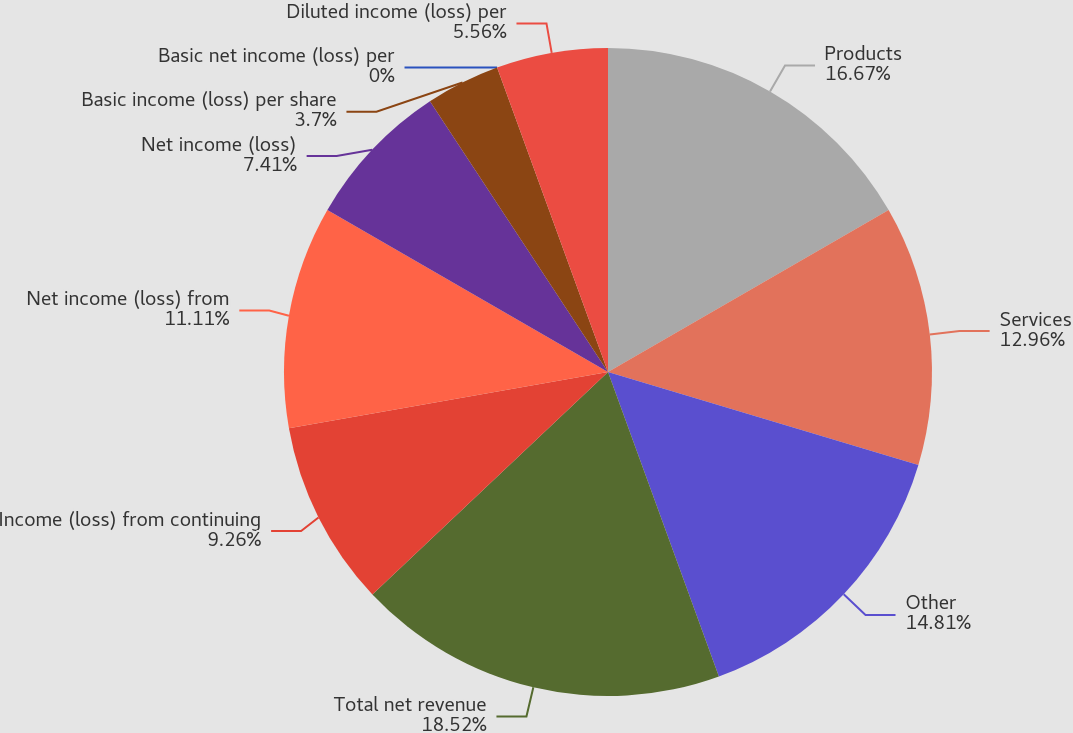<chart> <loc_0><loc_0><loc_500><loc_500><pie_chart><fcel>Products<fcel>Services<fcel>Other<fcel>Total net revenue<fcel>Income (loss) from continuing<fcel>Net income (loss) from<fcel>Net income (loss)<fcel>Basic income (loss) per share<fcel>Basic net income (loss) per<fcel>Diluted income (loss) per<nl><fcel>16.67%<fcel>12.96%<fcel>14.81%<fcel>18.52%<fcel>9.26%<fcel>11.11%<fcel>7.41%<fcel>3.7%<fcel>0.0%<fcel>5.56%<nl></chart> 